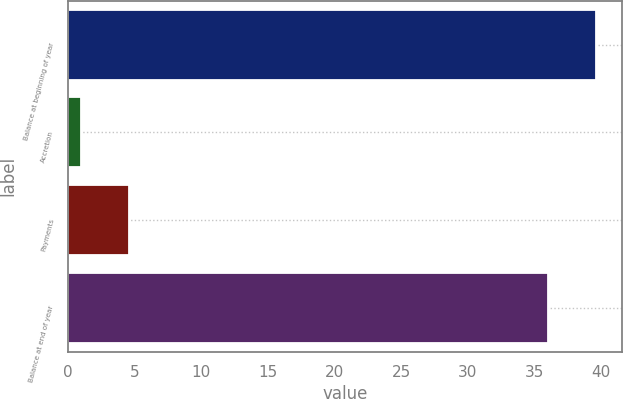<chart> <loc_0><loc_0><loc_500><loc_500><bar_chart><fcel>Balance at beginning of year<fcel>Accretion<fcel>Payments<fcel>Balance at end of year<nl><fcel>39.6<fcel>1<fcel>4.6<fcel>36<nl></chart> 